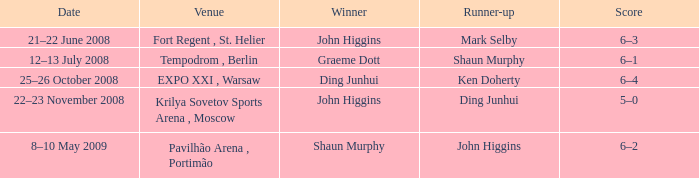When did the game take place where shaun murphy was the second-place finisher? 12–13 July 2008. 